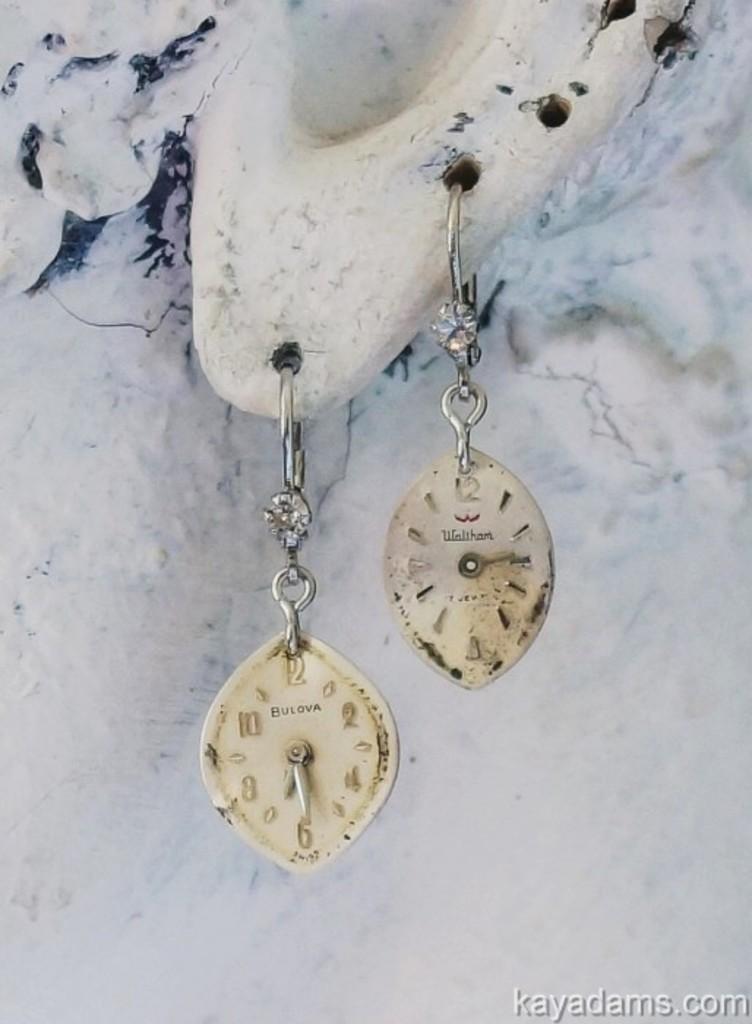Describe this image in one or two sentences. In this image I can see a cream color earrings. Background is white in color. 